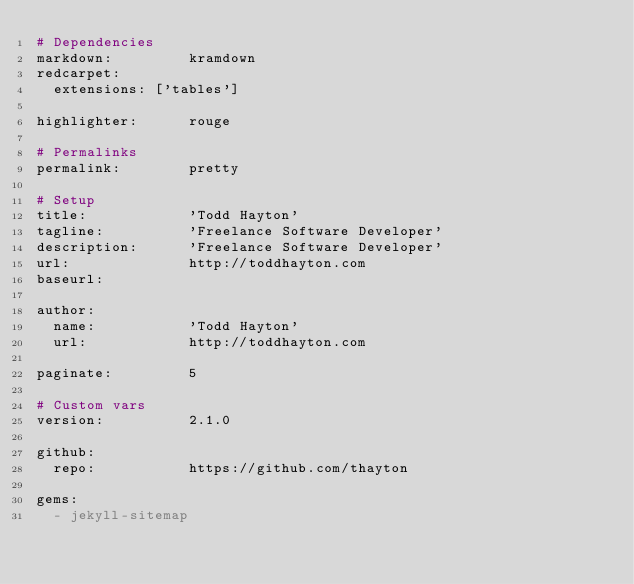Convert code to text. <code><loc_0><loc_0><loc_500><loc_500><_YAML_># Dependencies
markdown:         kramdown
redcarpet:
  extensions: ['tables']

highlighter:      rouge

# Permalinks
permalink:        pretty

# Setup
title:            'Todd Hayton'
tagline:          'Freelance Software Developer'
description:      'Freelance Software Developer'
url:              http://toddhayton.com
baseurl:          

author:
  name:           'Todd Hayton'
  url:            http://toddhayton.com

paginate:         5

# Custom vars
version:          2.1.0

github:
  repo:           https://github.com/thayton

gems:
  - jekyll-sitemap
</code> 